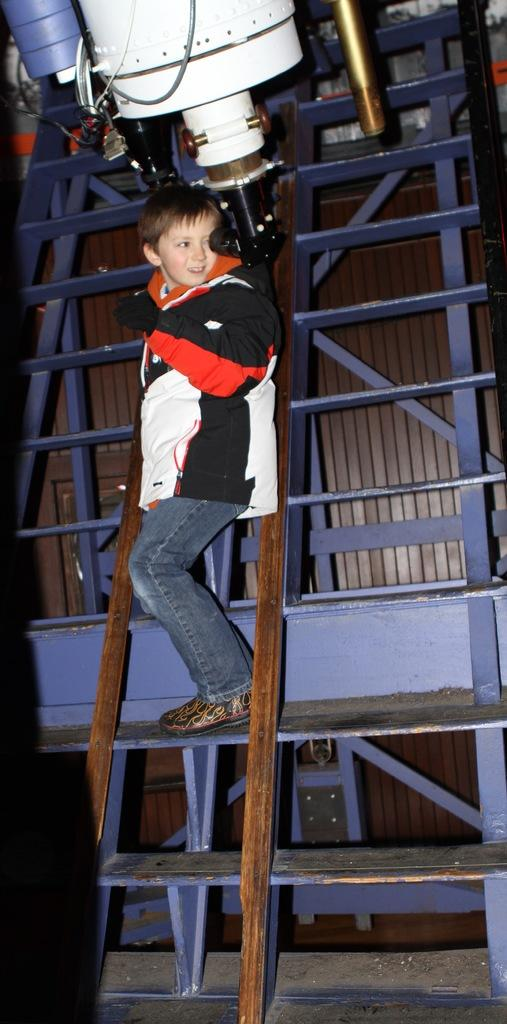Who is the main subject in the image? There is a boy in the image. What is the boy wearing on his hands? The boy is wearing gloves. What is the boy standing on in the image? The boy is standing on a ladder. Can you describe the white object in the image? There is a white color object in the image, but its specific details are not mentioned in the facts. Is there a tent set up near the boy in the image? There is no mention of a tent in the image, so we cannot confirm its presence. 